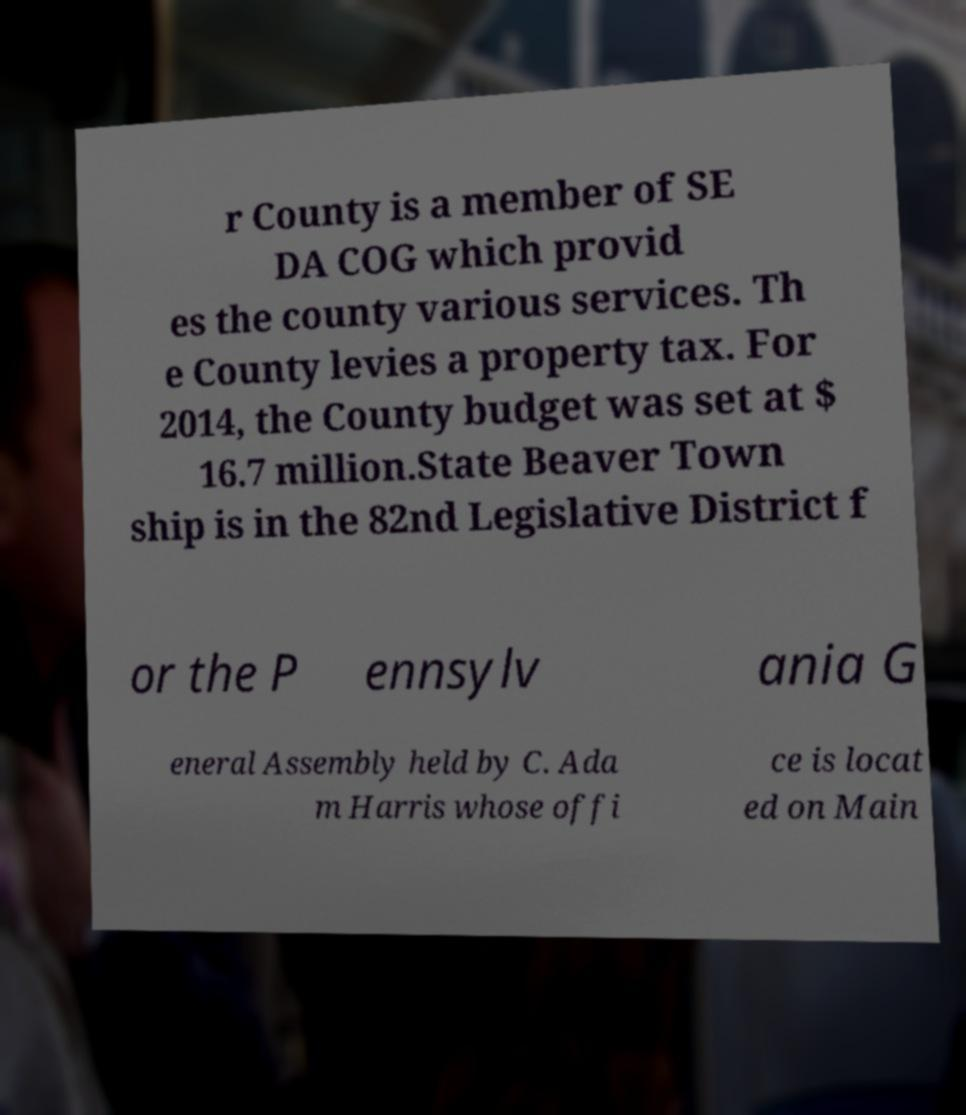Could you extract and type out the text from this image? r County is a member of SE DA COG which provid es the county various services. Th e County levies a property tax. For 2014, the County budget was set at $ 16.7 million.State Beaver Town ship is in the 82nd Legislative District f or the P ennsylv ania G eneral Assembly held by C. Ada m Harris whose offi ce is locat ed on Main 